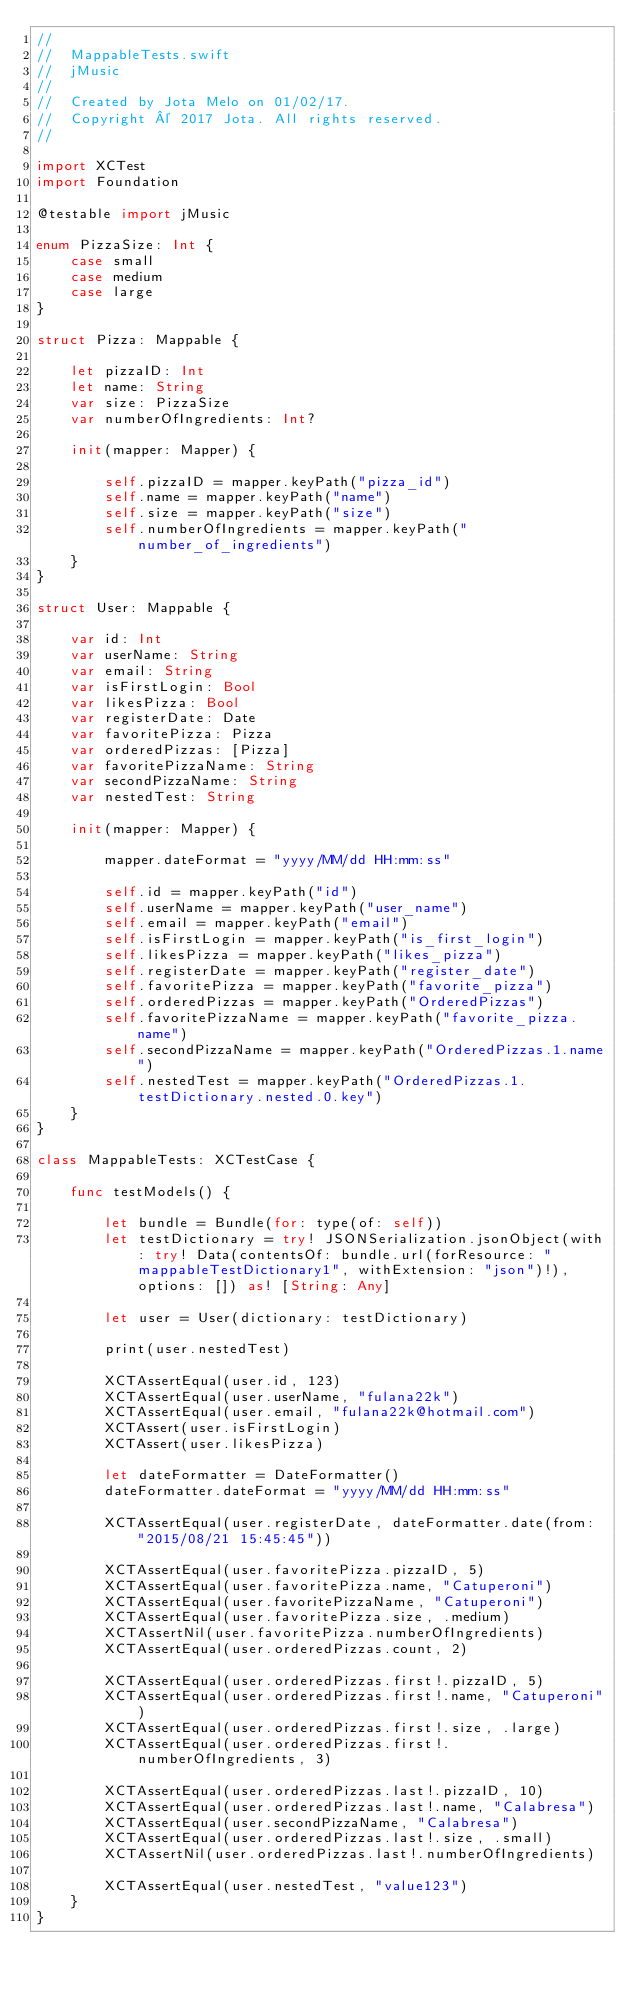Convert code to text. <code><loc_0><loc_0><loc_500><loc_500><_Swift_>//
//  MappableTests.swift
//  jMusic
//
//  Created by Jota Melo on 01/02/17.
//  Copyright © 2017 Jota. All rights reserved.
//

import XCTest
import Foundation

@testable import jMusic

enum PizzaSize: Int {
    case small
    case medium
    case large
}

struct Pizza: Mappable {
    
    let pizzaID: Int
    let name: String
    var size: PizzaSize
    var numberOfIngredients: Int?
    
    init(mapper: Mapper) {
        
        self.pizzaID = mapper.keyPath("pizza_id")
        self.name = mapper.keyPath("name")
        self.size = mapper.keyPath("size")
        self.numberOfIngredients = mapper.keyPath("number_of_ingredients")
    }
}

struct User: Mappable {
    
    var id: Int
    var userName: String
    var email: String
    var isFirstLogin: Bool
    var likesPizza: Bool
    var registerDate: Date
    var favoritePizza: Pizza
    var orderedPizzas: [Pizza]
    var favoritePizzaName: String
    var secondPizzaName: String
    var nestedTest: String
    
    init(mapper: Mapper) {
        
        mapper.dateFormat = "yyyy/MM/dd HH:mm:ss"
        
        self.id = mapper.keyPath("id")
        self.userName = mapper.keyPath("user_name")
        self.email = mapper.keyPath("email")
        self.isFirstLogin = mapper.keyPath("is_first_login")
        self.likesPizza = mapper.keyPath("likes_pizza")
        self.registerDate = mapper.keyPath("register_date")
        self.favoritePizza = mapper.keyPath("favorite_pizza")
        self.orderedPizzas = mapper.keyPath("OrderedPizzas")
        self.favoritePizzaName = mapper.keyPath("favorite_pizza.name")
        self.secondPizzaName = mapper.keyPath("OrderedPizzas.1.name")
        self.nestedTest = mapper.keyPath("OrderedPizzas.1.testDictionary.nested.0.key")
    }
}

class MappableTests: XCTestCase {

    func testModels() {
        
        let bundle = Bundle(for: type(of: self))
        let testDictionary = try! JSONSerialization.jsonObject(with: try! Data(contentsOf: bundle.url(forResource: "mappableTestDictionary1", withExtension: "json")!), options: []) as! [String: Any]
        
        let user = User(dictionary: testDictionary)
        
        print(user.nestedTest)
        
        XCTAssertEqual(user.id, 123)
        XCTAssertEqual(user.userName, "fulana22k")
        XCTAssertEqual(user.email, "fulana22k@hotmail.com")
        XCTAssert(user.isFirstLogin)
        XCTAssert(user.likesPizza)
        
        let dateFormatter = DateFormatter()
        dateFormatter.dateFormat = "yyyy/MM/dd HH:mm:ss"
        
        XCTAssertEqual(user.registerDate, dateFormatter.date(from: "2015/08/21 15:45:45"))
        
        XCTAssertEqual(user.favoritePizza.pizzaID, 5)
        XCTAssertEqual(user.favoritePizza.name, "Catuperoni")
        XCTAssertEqual(user.favoritePizzaName, "Catuperoni")
        XCTAssertEqual(user.favoritePizza.size, .medium)
        XCTAssertNil(user.favoritePizza.numberOfIngredients)
        XCTAssertEqual(user.orderedPizzas.count, 2)
        
        XCTAssertEqual(user.orderedPizzas.first!.pizzaID, 5)
        XCTAssertEqual(user.orderedPizzas.first!.name, "Catuperoni")
        XCTAssertEqual(user.orderedPizzas.first!.size, .large)
        XCTAssertEqual(user.orderedPizzas.first!.numberOfIngredients, 3)
        
        XCTAssertEqual(user.orderedPizzas.last!.pizzaID, 10)
        XCTAssertEqual(user.orderedPizzas.last!.name, "Calabresa")
        XCTAssertEqual(user.secondPizzaName, "Calabresa")
        XCTAssertEqual(user.orderedPizzas.last!.size, .small)
        XCTAssertNil(user.orderedPizzas.last!.numberOfIngredients)
        
        XCTAssertEqual(user.nestedTest, "value123")
    }
}
</code> 